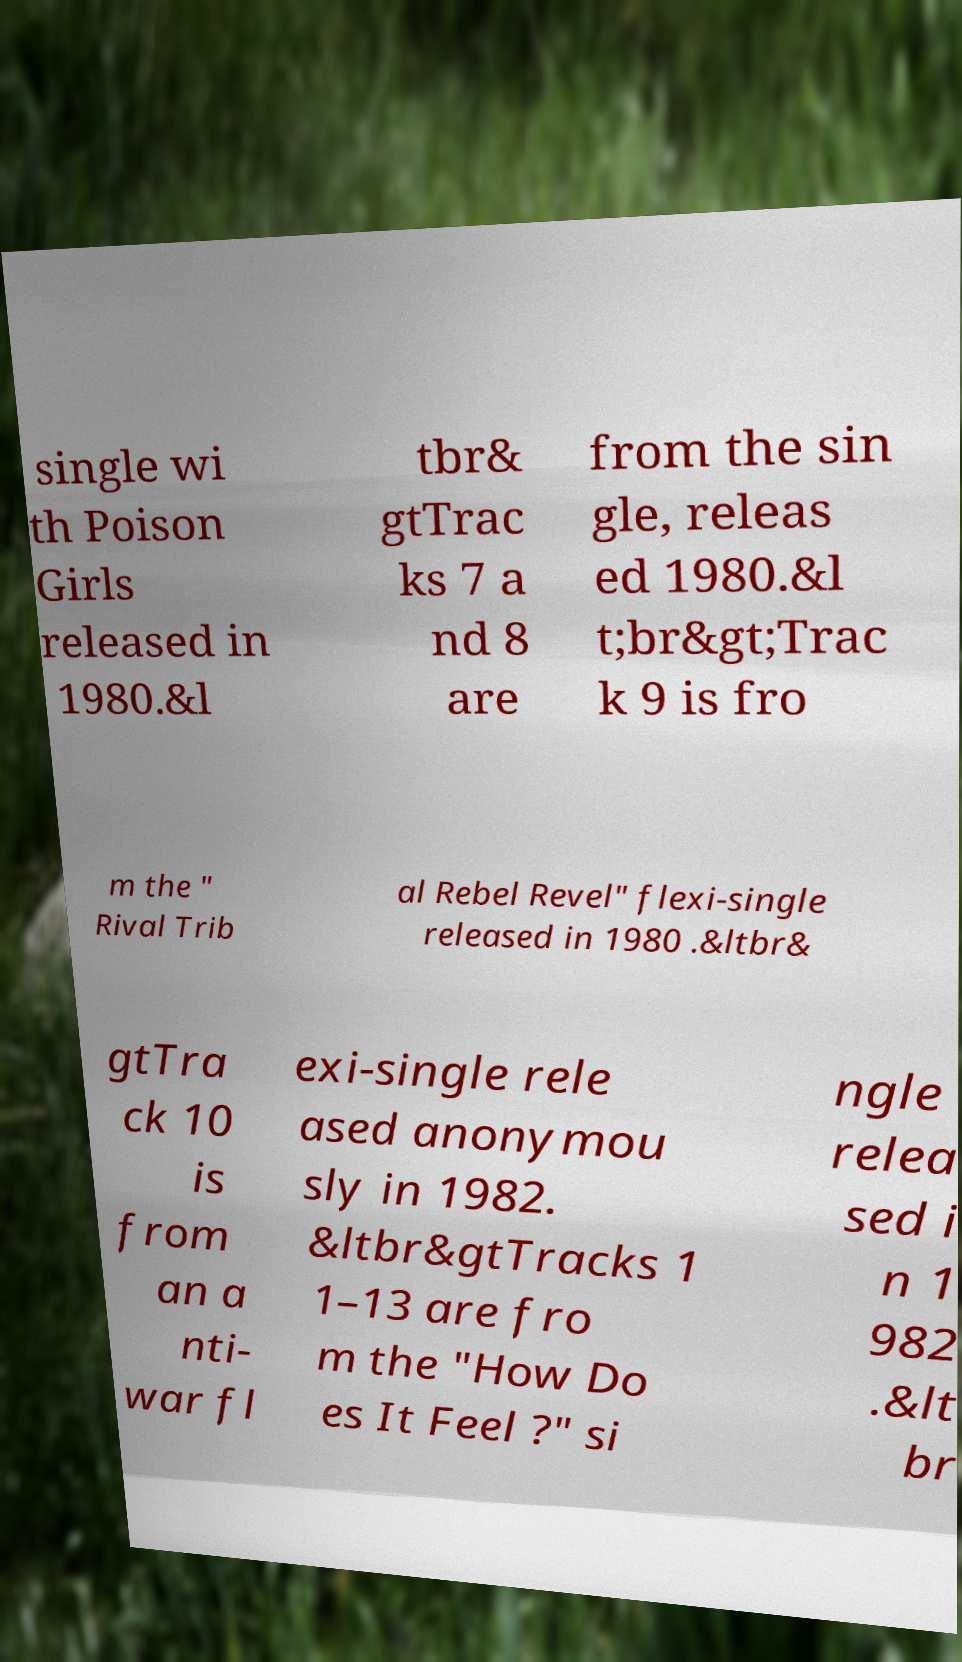Can you read and provide the text displayed in the image?This photo seems to have some interesting text. Can you extract and type it out for me? single wi th Poison Girls released in 1980.&l tbr& gtTrac ks 7 a nd 8 are from the sin gle, releas ed 1980.&l t;br&gt;Trac k 9 is fro m the " Rival Trib al Rebel Revel" flexi-single released in 1980 .&ltbr& gtTra ck 10 is from an a nti- war fl exi-single rele ased anonymou sly in 1982. &ltbr&gtTracks 1 1–13 are fro m the "How Do es It Feel ?" si ngle relea sed i n 1 982 .&lt br 